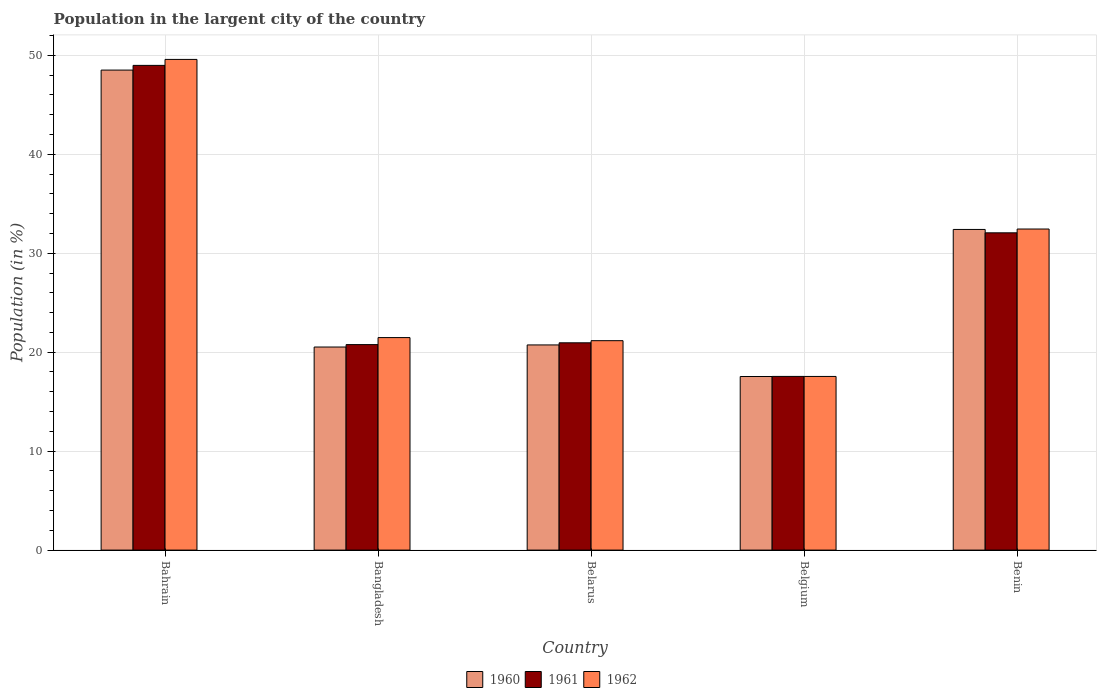Are the number of bars per tick equal to the number of legend labels?
Ensure brevity in your answer.  Yes. What is the label of the 1st group of bars from the left?
Your answer should be compact. Bahrain. What is the percentage of population in the largent city in 1960 in Belgium?
Your answer should be compact. 17.54. Across all countries, what is the maximum percentage of population in the largent city in 1960?
Your response must be concise. 48.51. Across all countries, what is the minimum percentage of population in the largent city in 1962?
Keep it short and to the point. 17.55. In which country was the percentage of population in the largent city in 1961 maximum?
Make the answer very short. Bahrain. What is the total percentage of population in the largent city in 1960 in the graph?
Ensure brevity in your answer.  139.71. What is the difference between the percentage of population in the largent city in 1962 in Bahrain and that in Bangladesh?
Offer a terse response. 28.11. What is the difference between the percentage of population in the largent city in 1961 in Belgium and the percentage of population in the largent city in 1960 in Bangladesh?
Provide a short and direct response. -2.97. What is the average percentage of population in the largent city in 1960 per country?
Your answer should be compact. 27.94. What is the difference between the percentage of population in the largent city of/in 1962 and percentage of population in the largent city of/in 1961 in Benin?
Provide a short and direct response. 0.38. What is the ratio of the percentage of population in the largent city in 1960 in Bangladesh to that in Benin?
Give a very brief answer. 0.63. Is the percentage of population in the largent city in 1962 in Belgium less than that in Benin?
Your answer should be compact. Yes. What is the difference between the highest and the second highest percentage of population in the largent city in 1961?
Ensure brevity in your answer.  16.92. What is the difference between the highest and the lowest percentage of population in the largent city in 1962?
Keep it short and to the point. 32.04. In how many countries, is the percentage of population in the largent city in 1962 greater than the average percentage of population in the largent city in 1962 taken over all countries?
Your answer should be compact. 2. Is the sum of the percentage of population in the largent city in 1962 in Bangladesh and Benin greater than the maximum percentage of population in the largent city in 1960 across all countries?
Offer a very short reply. Yes. What does the 1st bar from the right in Bahrain represents?
Give a very brief answer. 1962. How many bars are there?
Provide a succinct answer. 15. How many countries are there in the graph?
Provide a short and direct response. 5. How many legend labels are there?
Offer a very short reply. 3. How are the legend labels stacked?
Provide a short and direct response. Horizontal. What is the title of the graph?
Give a very brief answer. Population in the largent city of the country. What is the label or title of the X-axis?
Your answer should be compact. Country. What is the label or title of the Y-axis?
Offer a terse response. Population (in %). What is the Population (in %) in 1960 in Bahrain?
Ensure brevity in your answer.  48.51. What is the Population (in %) of 1961 in Bahrain?
Give a very brief answer. 48.98. What is the Population (in %) of 1962 in Bahrain?
Your answer should be compact. 49.59. What is the Population (in %) in 1960 in Bangladesh?
Your answer should be very brief. 20.52. What is the Population (in %) of 1961 in Bangladesh?
Ensure brevity in your answer.  20.77. What is the Population (in %) in 1962 in Bangladesh?
Keep it short and to the point. 21.48. What is the Population (in %) of 1960 in Belarus?
Keep it short and to the point. 20.73. What is the Population (in %) of 1961 in Belarus?
Offer a terse response. 20.95. What is the Population (in %) in 1962 in Belarus?
Your answer should be compact. 21.16. What is the Population (in %) in 1960 in Belgium?
Your answer should be compact. 17.54. What is the Population (in %) in 1961 in Belgium?
Offer a very short reply. 17.55. What is the Population (in %) of 1962 in Belgium?
Keep it short and to the point. 17.55. What is the Population (in %) in 1960 in Benin?
Your answer should be compact. 32.4. What is the Population (in %) of 1961 in Benin?
Provide a succinct answer. 32.06. What is the Population (in %) in 1962 in Benin?
Keep it short and to the point. 32.45. Across all countries, what is the maximum Population (in %) in 1960?
Provide a succinct answer. 48.51. Across all countries, what is the maximum Population (in %) in 1961?
Give a very brief answer. 48.98. Across all countries, what is the maximum Population (in %) in 1962?
Provide a short and direct response. 49.59. Across all countries, what is the minimum Population (in %) of 1960?
Offer a terse response. 17.54. Across all countries, what is the minimum Population (in %) in 1961?
Ensure brevity in your answer.  17.55. Across all countries, what is the minimum Population (in %) of 1962?
Offer a terse response. 17.55. What is the total Population (in %) in 1960 in the graph?
Make the answer very short. 139.71. What is the total Population (in %) in 1961 in the graph?
Keep it short and to the point. 140.31. What is the total Population (in %) in 1962 in the graph?
Provide a short and direct response. 142.22. What is the difference between the Population (in %) in 1960 in Bahrain and that in Bangladesh?
Provide a short and direct response. 27.99. What is the difference between the Population (in %) in 1961 in Bahrain and that in Bangladesh?
Your answer should be compact. 28.22. What is the difference between the Population (in %) in 1962 in Bahrain and that in Bangladesh?
Your answer should be very brief. 28.11. What is the difference between the Population (in %) in 1960 in Bahrain and that in Belarus?
Your answer should be very brief. 27.77. What is the difference between the Population (in %) of 1961 in Bahrain and that in Belarus?
Make the answer very short. 28.03. What is the difference between the Population (in %) of 1962 in Bahrain and that in Belarus?
Your answer should be compact. 28.42. What is the difference between the Population (in %) of 1960 in Bahrain and that in Belgium?
Provide a succinct answer. 30.96. What is the difference between the Population (in %) of 1961 in Bahrain and that in Belgium?
Keep it short and to the point. 31.43. What is the difference between the Population (in %) in 1962 in Bahrain and that in Belgium?
Give a very brief answer. 32.04. What is the difference between the Population (in %) in 1960 in Bahrain and that in Benin?
Provide a succinct answer. 16.1. What is the difference between the Population (in %) of 1961 in Bahrain and that in Benin?
Keep it short and to the point. 16.92. What is the difference between the Population (in %) of 1962 in Bahrain and that in Benin?
Provide a short and direct response. 17.14. What is the difference between the Population (in %) in 1960 in Bangladesh and that in Belarus?
Ensure brevity in your answer.  -0.21. What is the difference between the Population (in %) of 1961 in Bangladesh and that in Belarus?
Your answer should be very brief. -0.18. What is the difference between the Population (in %) of 1962 in Bangladesh and that in Belarus?
Ensure brevity in your answer.  0.31. What is the difference between the Population (in %) of 1960 in Bangladesh and that in Belgium?
Provide a short and direct response. 2.98. What is the difference between the Population (in %) of 1961 in Bangladesh and that in Belgium?
Your answer should be compact. 3.22. What is the difference between the Population (in %) in 1962 in Bangladesh and that in Belgium?
Offer a terse response. 3.93. What is the difference between the Population (in %) in 1960 in Bangladesh and that in Benin?
Make the answer very short. -11.88. What is the difference between the Population (in %) of 1961 in Bangladesh and that in Benin?
Provide a succinct answer. -11.3. What is the difference between the Population (in %) of 1962 in Bangladesh and that in Benin?
Provide a succinct answer. -10.97. What is the difference between the Population (in %) of 1960 in Belarus and that in Belgium?
Provide a succinct answer. 3.19. What is the difference between the Population (in %) in 1961 in Belarus and that in Belgium?
Provide a short and direct response. 3.4. What is the difference between the Population (in %) in 1962 in Belarus and that in Belgium?
Provide a short and direct response. 3.61. What is the difference between the Population (in %) in 1960 in Belarus and that in Benin?
Your response must be concise. -11.67. What is the difference between the Population (in %) in 1961 in Belarus and that in Benin?
Give a very brief answer. -11.11. What is the difference between the Population (in %) of 1962 in Belarus and that in Benin?
Provide a succinct answer. -11.28. What is the difference between the Population (in %) of 1960 in Belgium and that in Benin?
Provide a short and direct response. -14.86. What is the difference between the Population (in %) of 1961 in Belgium and that in Benin?
Offer a very short reply. -14.51. What is the difference between the Population (in %) in 1962 in Belgium and that in Benin?
Offer a very short reply. -14.9. What is the difference between the Population (in %) of 1960 in Bahrain and the Population (in %) of 1961 in Bangladesh?
Offer a terse response. 27.74. What is the difference between the Population (in %) in 1960 in Bahrain and the Population (in %) in 1962 in Bangladesh?
Your answer should be very brief. 27.03. What is the difference between the Population (in %) in 1961 in Bahrain and the Population (in %) in 1962 in Bangladesh?
Ensure brevity in your answer.  27.51. What is the difference between the Population (in %) of 1960 in Bahrain and the Population (in %) of 1961 in Belarus?
Offer a very short reply. 27.56. What is the difference between the Population (in %) of 1960 in Bahrain and the Population (in %) of 1962 in Belarus?
Make the answer very short. 27.34. What is the difference between the Population (in %) of 1961 in Bahrain and the Population (in %) of 1962 in Belarus?
Offer a terse response. 27.82. What is the difference between the Population (in %) of 1960 in Bahrain and the Population (in %) of 1961 in Belgium?
Give a very brief answer. 30.96. What is the difference between the Population (in %) in 1960 in Bahrain and the Population (in %) in 1962 in Belgium?
Keep it short and to the point. 30.96. What is the difference between the Population (in %) in 1961 in Bahrain and the Population (in %) in 1962 in Belgium?
Your answer should be compact. 31.43. What is the difference between the Population (in %) of 1960 in Bahrain and the Population (in %) of 1961 in Benin?
Provide a short and direct response. 16.44. What is the difference between the Population (in %) of 1960 in Bahrain and the Population (in %) of 1962 in Benin?
Provide a succinct answer. 16.06. What is the difference between the Population (in %) in 1961 in Bahrain and the Population (in %) in 1962 in Benin?
Provide a succinct answer. 16.54. What is the difference between the Population (in %) of 1960 in Bangladesh and the Population (in %) of 1961 in Belarus?
Provide a short and direct response. -0.43. What is the difference between the Population (in %) of 1960 in Bangladesh and the Population (in %) of 1962 in Belarus?
Make the answer very short. -0.64. What is the difference between the Population (in %) of 1961 in Bangladesh and the Population (in %) of 1962 in Belarus?
Make the answer very short. -0.4. What is the difference between the Population (in %) of 1960 in Bangladesh and the Population (in %) of 1961 in Belgium?
Ensure brevity in your answer.  2.97. What is the difference between the Population (in %) in 1960 in Bangladesh and the Population (in %) in 1962 in Belgium?
Your answer should be very brief. 2.97. What is the difference between the Population (in %) in 1961 in Bangladesh and the Population (in %) in 1962 in Belgium?
Offer a very short reply. 3.22. What is the difference between the Population (in %) in 1960 in Bangladesh and the Population (in %) in 1961 in Benin?
Offer a very short reply. -11.54. What is the difference between the Population (in %) of 1960 in Bangladesh and the Population (in %) of 1962 in Benin?
Your response must be concise. -11.92. What is the difference between the Population (in %) in 1961 in Bangladesh and the Population (in %) in 1962 in Benin?
Offer a terse response. -11.68. What is the difference between the Population (in %) of 1960 in Belarus and the Population (in %) of 1961 in Belgium?
Offer a terse response. 3.18. What is the difference between the Population (in %) in 1960 in Belarus and the Population (in %) in 1962 in Belgium?
Ensure brevity in your answer.  3.18. What is the difference between the Population (in %) of 1960 in Belarus and the Population (in %) of 1961 in Benin?
Provide a succinct answer. -11.33. What is the difference between the Population (in %) of 1960 in Belarus and the Population (in %) of 1962 in Benin?
Your response must be concise. -11.71. What is the difference between the Population (in %) of 1961 in Belarus and the Population (in %) of 1962 in Benin?
Make the answer very short. -11.5. What is the difference between the Population (in %) of 1960 in Belgium and the Population (in %) of 1961 in Benin?
Your answer should be very brief. -14.52. What is the difference between the Population (in %) of 1960 in Belgium and the Population (in %) of 1962 in Benin?
Your response must be concise. -14.9. What is the difference between the Population (in %) of 1961 in Belgium and the Population (in %) of 1962 in Benin?
Ensure brevity in your answer.  -14.89. What is the average Population (in %) of 1960 per country?
Your answer should be very brief. 27.94. What is the average Population (in %) in 1961 per country?
Provide a short and direct response. 28.06. What is the average Population (in %) of 1962 per country?
Your answer should be very brief. 28.44. What is the difference between the Population (in %) in 1960 and Population (in %) in 1961 in Bahrain?
Your answer should be very brief. -0.48. What is the difference between the Population (in %) in 1960 and Population (in %) in 1962 in Bahrain?
Make the answer very short. -1.08. What is the difference between the Population (in %) of 1961 and Population (in %) of 1962 in Bahrain?
Your answer should be compact. -0.6. What is the difference between the Population (in %) in 1960 and Population (in %) in 1961 in Bangladesh?
Provide a succinct answer. -0.24. What is the difference between the Population (in %) of 1960 and Population (in %) of 1962 in Bangladesh?
Give a very brief answer. -0.95. What is the difference between the Population (in %) of 1961 and Population (in %) of 1962 in Bangladesh?
Make the answer very short. -0.71. What is the difference between the Population (in %) of 1960 and Population (in %) of 1961 in Belarus?
Make the answer very short. -0.22. What is the difference between the Population (in %) in 1960 and Population (in %) in 1962 in Belarus?
Offer a very short reply. -0.43. What is the difference between the Population (in %) in 1961 and Population (in %) in 1962 in Belarus?
Offer a very short reply. -0.21. What is the difference between the Population (in %) in 1960 and Population (in %) in 1961 in Belgium?
Your response must be concise. -0.01. What is the difference between the Population (in %) of 1960 and Population (in %) of 1962 in Belgium?
Give a very brief answer. -0.01. What is the difference between the Population (in %) in 1961 and Population (in %) in 1962 in Belgium?
Your response must be concise. 0. What is the difference between the Population (in %) in 1960 and Population (in %) in 1961 in Benin?
Provide a short and direct response. 0.34. What is the difference between the Population (in %) in 1960 and Population (in %) in 1962 in Benin?
Your answer should be compact. -0.04. What is the difference between the Population (in %) in 1961 and Population (in %) in 1962 in Benin?
Make the answer very short. -0.38. What is the ratio of the Population (in %) in 1960 in Bahrain to that in Bangladesh?
Give a very brief answer. 2.36. What is the ratio of the Population (in %) in 1961 in Bahrain to that in Bangladesh?
Keep it short and to the point. 2.36. What is the ratio of the Population (in %) in 1962 in Bahrain to that in Bangladesh?
Your answer should be compact. 2.31. What is the ratio of the Population (in %) in 1960 in Bahrain to that in Belarus?
Provide a short and direct response. 2.34. What is the ratio of the Population (in %) of 1961 in Bahrain to that in Belarus?
Provide a succinct answer. 2.34. What is the ratio of the Population (in %) of 1962 in Bahrain to that in Belarus?
Give a very brief answer. 2.34. What is the ratio of the Population (in %) in 1960 in Bahrain to that in Belgium?
Your answer should be compact. 2.77. What is the ratio of the Population (in %) of 1961 in Bahrain to that in Belgium?
Your answer should be very brief. 2.79. What is the ratio of the Population (in %) in 1962 in Bahrain to that in Belgium?
Offer a terse response. 2.83. What is the ratio of the Population (in %) of 1960 in Bahrain to that in Benin?
Ensure brevity in your answer.  1.5. What is the ratio of the Population (in %) of 1961 in Bahrain to that in Benin?
Keep it short and to the point. 1.53. What is the ratio of the Population (in %) of 1962 in Bahrain to that in Benin?
Give a very brief answer. 1.53. What is the ratio of the Population (in %) of 1960 in Bangladesh to that in Belarus?
Your answer should be very brief. 0.99. What is the ratio of the Population (in %) of 1961 in Bangladesh to that in Belarus?
Your answer should be very brief. 0.99. What is the ratio of the Population (in %) of 1962 in Bangladesh to that in Belarus?
Your answer should be very brief. 1.01. What is the ratio of the Population (in %) of 1960 in Bangladesh to that in Belgium?
Your answer should be very brief. 1.17. What is the ratio of the Population (in %) of 1961 in Bangladesh to that in Belgium?
Your response must be concise. 1.18. What is the ratio of the Population (in %) of 1962 in Bangladesh to that in Belgium?
Provide a short and direct response. 1.22. What is the ratio of the Population (in %) of 1960 in Bangladesh to that in Benin?
Your response must be concise. 0.63. What is the ratio of the Population (in %) of 1961 in Bangladesh to that in Benin?
Your answer should be compact. 0.65. What is the ratio of the Population (in %) in 1962 in Bangladesh to that in Benin?
Ensure brevity in your answer.  0.66. What is the ratio of the Population (in %) in 1960 in Belarus to that in Belgium?
Provide a short and direct response. 1.18. What is the ratio of the Population (in %) in 1961 in Belarus to that in Belgium?
Provide a succinct answer. 1.19. What is the ratio of the Population (in %) of 1962 in Belarus to that in Belgium?
Your answer should be compact. 1.21. What is the ratio of the Population (in %) of 1960 in Belarus to that in Benin?
Your answer should be very brief. 0.64. What is the ratio of the Population (in %) in 1961 in Belarus to that in Benin?
Offer a very short reply. 0.65. What is the ratio of the Population (in %) of 1962 in Belarus to that in Benin?
Ensure brevity in your answer.  0.65. What is the ratio of the Population (in %) in 1960 in Belgium to that in Benin?
Provide a succinct answer. 0.54. What is the ratio of the Population (in %) in 1961 in Belgium to that in Benin?
Make the answer very short. 0.55. What is the ratio of the Population (in %) of 1962 in Belgium to that in Benin?
Provide a short and direct response. 0.54. What is the difference between the highest and the second highest Population (in %) in 1960?
Offer a very short reply. 16.1. What is the difference between the highest and the second highest Population (in %) of 1961?
Offer a terse response. 16.92. What is the difference between the highest and the second highest Population (in %) in 1962?
Keep it short and to the point. 17.14. What is the difference between the highest and the lowest Population (in %) of 1960?
Provide a succinct answer. 30.96. What is the difference between the highest and the lowest Population (in %) of 1961?
Provide a succinct answer. 31.43. What is the difference between the highest and the lowest Population (in %) of 1962?
Your answer should be very brief. 32.04. 